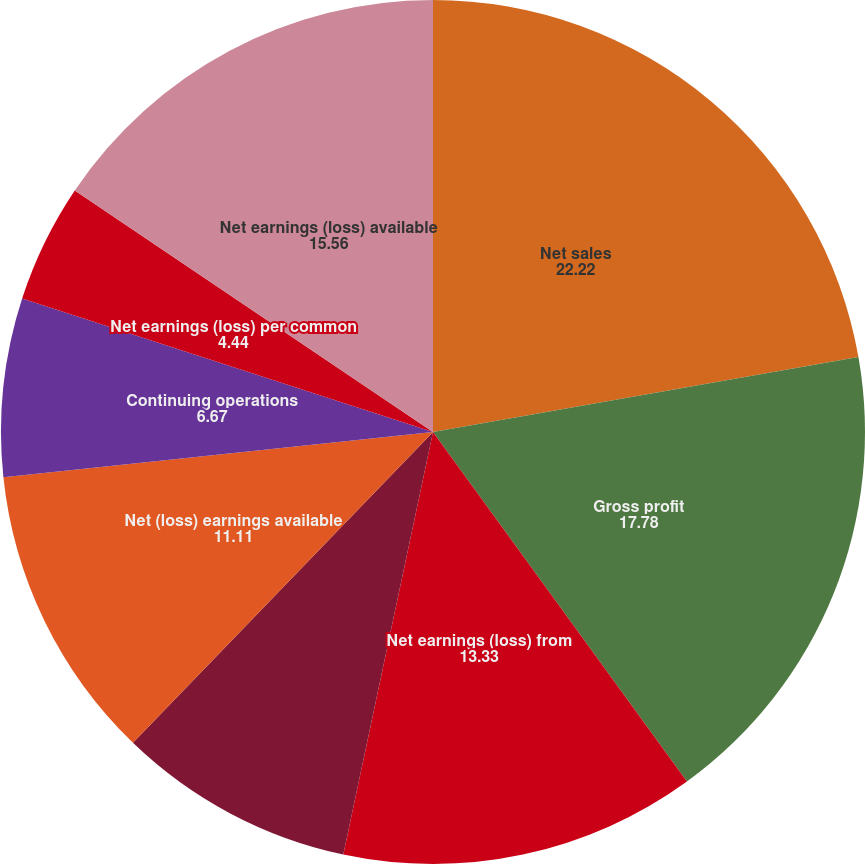Convert chart. <chart><loc_0><loc_0><loc_500><loc_500><pie_chart><fcel>Net sales<fcel>Gross profit<fcel>Net earnings (loss) from<fcel>Net earnings from discontinued<fcel>Net (loss) earnings available<fcel>Continuing operations<fcel>Discontinued operations<fcel>Net earnings (loss) per common<fcel>Net earnings (loss) available<nl><fcel>22.22%<fcel>17.78%<fcel>13.33%<fcel>8.89%<fcel>11.11%<fcel>6.67%<fcel>0.0%<fcel>4.44%<fcel>15.56%<nl></chart> 